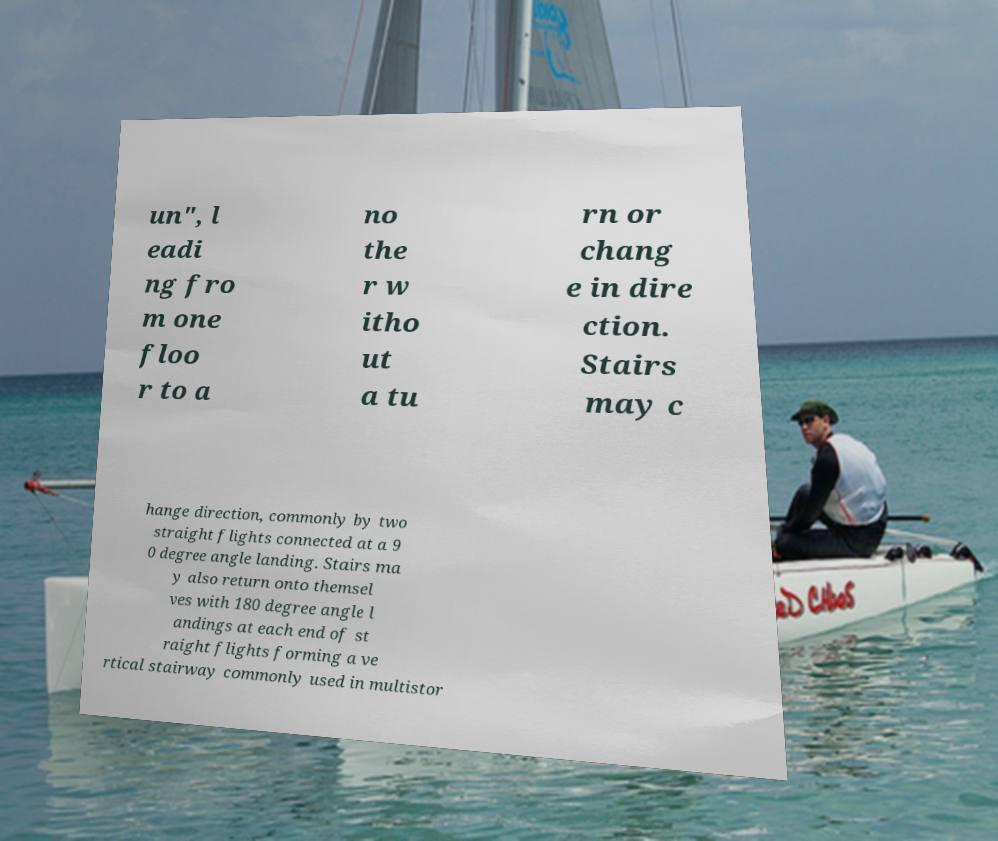What messages or text are displayed in this image? I need them in a readable, typed format. un", l eadi ng fro m one floo r to a no the r w itho ut a tu rn or chang e in dire ction. Stairs may c hange direction, commonly by two straight flights connected at a 9 0 degree angle landing. Stairs ma y also return onto themsel ves with 180 degree angle l andings at each end of st raight flights forming a ve rtical stairway commonly used in multistor 